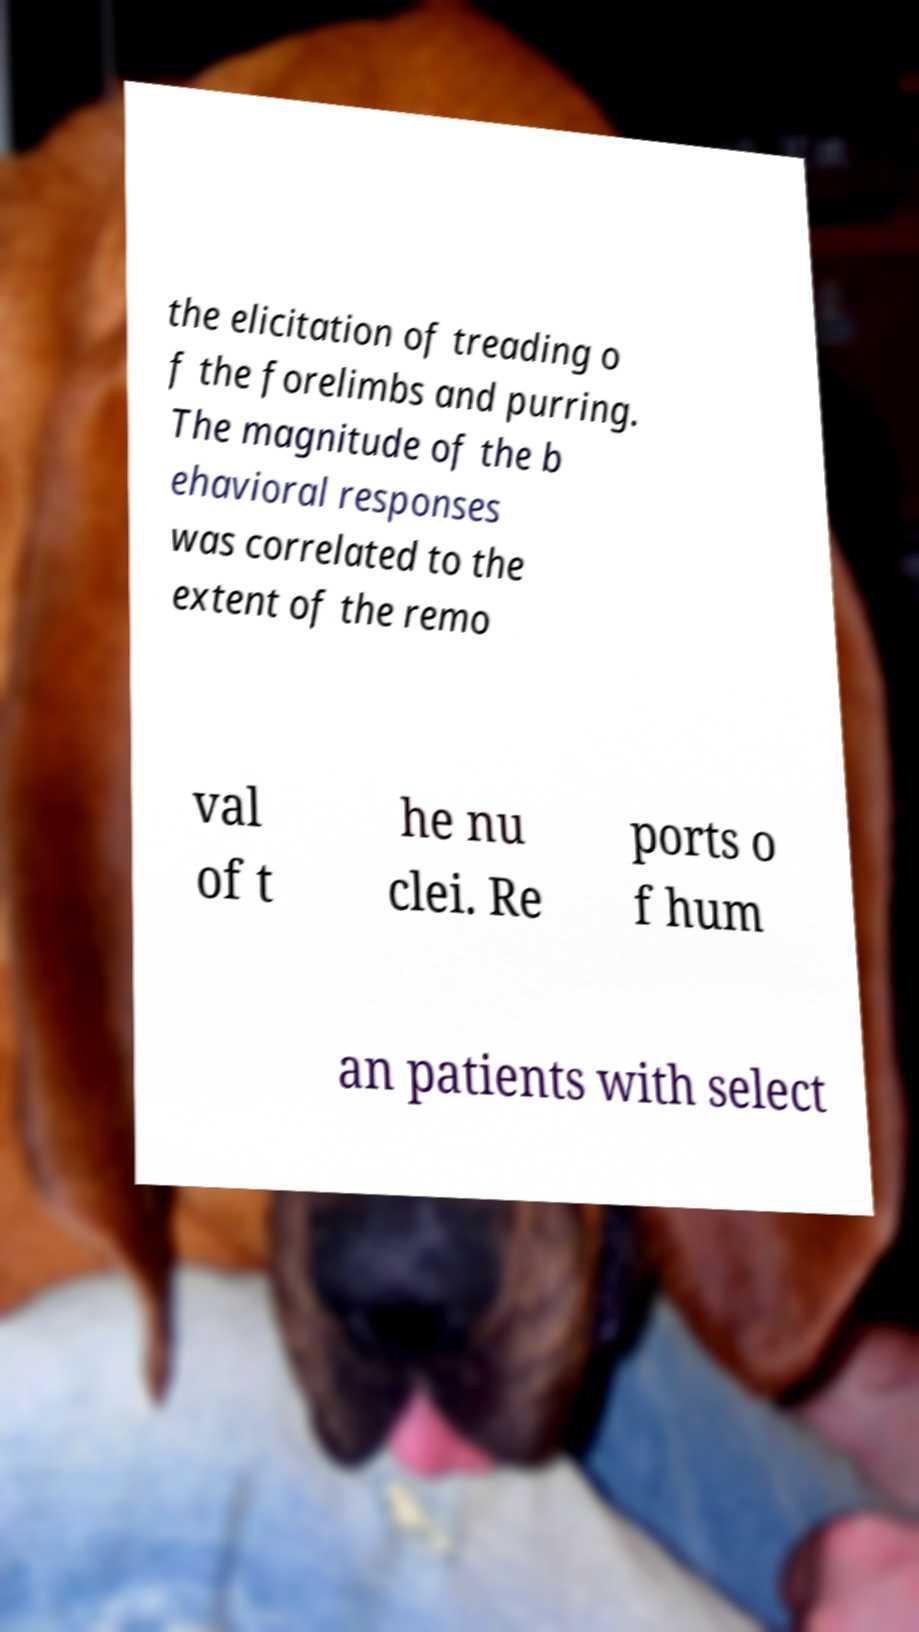Please identify and transcribe the text found in this image. the elicitation of treading o f the forelimbs and purring. The magnitude of the b ehavioral responses was correlated to the extent of the remo val of t he nu clei. Re ports o f hum an patients with select 